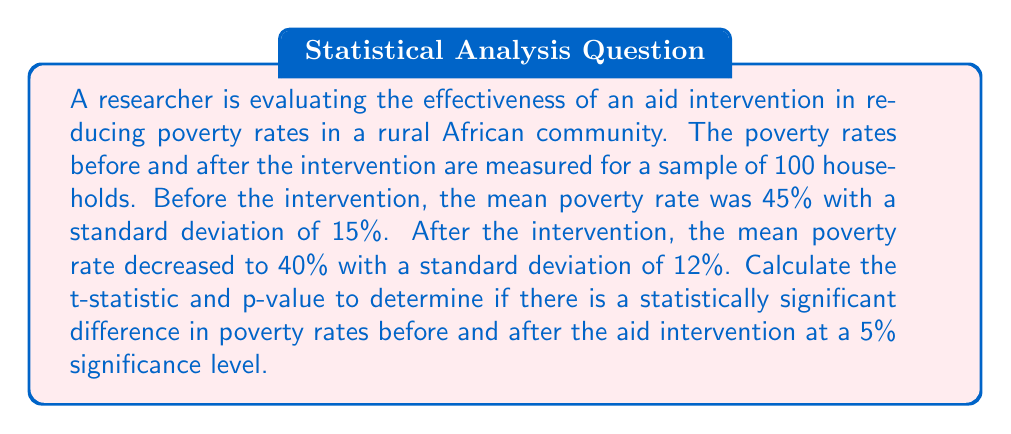Teach me how to tackle this problem. To determine if there is a statistically significant difference in poverty rates, we'll use a paired t-test since we're comparing the same households before and after the intervention.

Step 1: Calculate the standard error of the difference
The standard error (SE) of the difference is given by:

$$SE = \sqrt{\frac{s_1^2}{n} + \frac{s_2^2}{n} - 2r\frac{s_1s_2}{\sqrt{n}}}$$

Where $s_1$ and $s_2$ are the standard deviations, $n$ is the sample size, and $r$ is the correlation between the two samples. Since we don't know $r$, we'll assume it's 0 for a conservative estimate.

$$SE = \sqrt{\frac{15^2}{100} + \frac{12^2}{100}} = \sqrt{2.25 + 1.44} = \sqrt{3.69} = 1.92$$

Step 2: Calculate the t-statistic
The t-statistic is calculated as:

$$t = \frac{\bar{x}_1 - \bar{x}_2}{SE}$$

Where $\bar{x}_1$ and $\bar{x}_2$ are the means before and after the intervention.

$$t = \frac{45 - 40}{1.92} = 2.60$$

Step 3: Calculate the degrees of freedom
For a paired t-test, df = n - 1 = 100 - 1 = 99

Step 4: Determine the critical t-value
For a two-tailed test at 5% significance level with 99 df, the critical t-value is approximately 1.984.

Step 5: Calculate the p-value
Using a t-distribution calculator or table, we find that the p-value for t = 2.60 with 99 df is approximately 0.0107.

Step 6: Interpret the results
Since the calculated t-statistic (2.60) is greater than the critical t-value (1.984) and the p-value (0.0107) is less than the significance level (0.05), we reject the null hypothesis.
Answer: t-statistic = 2.60, p-value = 0.0107. Statistically significant difference at 5% level. 